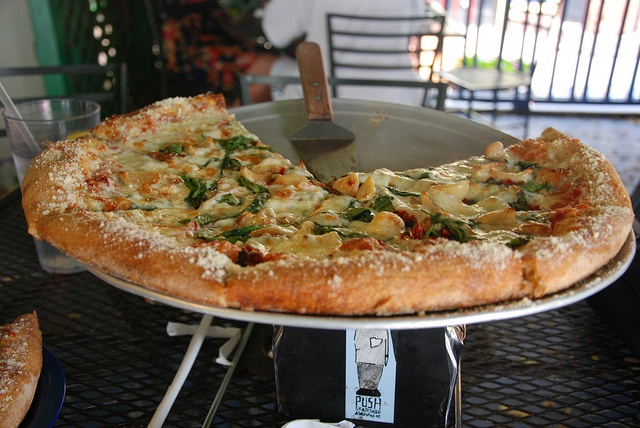Describe the objects in this image and their specific colors. I can see pizza in gray, brown, tan, and olive tones, chair in gray, darkgray, and white tones, cup in gray, black, and darkgreen tones, knife in gray, black, and maroon tones, and chair in gray, black, and darkgreen tones in this image. 